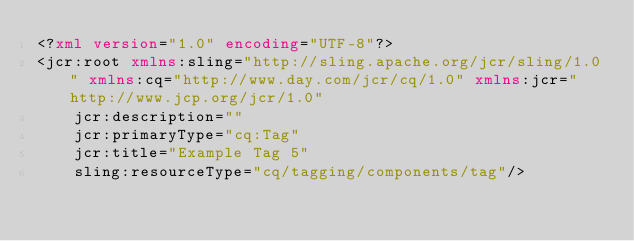<code> <loc_0><loc_0><loc_500><loc_500><_XML_><?xml version="1.0" encoding="UTF-8"?>
<jcr:root xmlns:sling="http://sling.apache.org/jcr/sling/1.0" xmlns:cq="http://www.day.com/jcr/cq/1.0" xmlns:jcr="http://www.jcp.org/jcr/1.0"
    jcr:description=""
    jcr:primaryType="cq:Tag"
    jcr:title="Example Tag 5"
    sling:resourceType="cq/tagging/components/tag"/>
</code> 